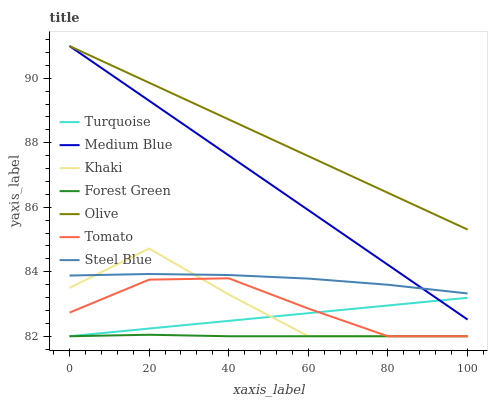Does Forest Green have the minimum area under the curve?
Answer yes or no. Yes. Does Olive have the maximum area under the curve?
Answer yes or no. Yes. Does Turquoise have the minimum area under the curve?
Answer yes or no. No. Does Turquoise have the maximum area under the curve?
Answer yes or no. No. Is Medium Blue the smoothest?
Answer yes or no. Yes. Is Khaki the roughest?
Answer yes or no. Yes. Is Turquoise the smoothest?
Answer yes or no. No. Is Turquoise the roughest?
Answer yes or no. No. Does Tomato have the lowest value?
Answer yes or no. Yes. Does Medium Blue have the lowest value?
Answer yes or no. No. Does Olive have the highest value?
Answer yes or no. Yes. Does Turquoise have the highest value?
Answer yes or no. No. Is Khaki less than Medium Blue?
Answer yes or no. Yes. Is Medium Blue greater than Forest Green?
Answer yes or no. Yes. Does Turquoise intersect Tomato?
Answer yes or no. Yes. Is Turquoise less than Tomato?
Answer yes or no. No. Is Turquoise greater than Tomato?
Answer yes or no. No. Does Khaki intersect Medium Blue?
Answer yes or no. No. 